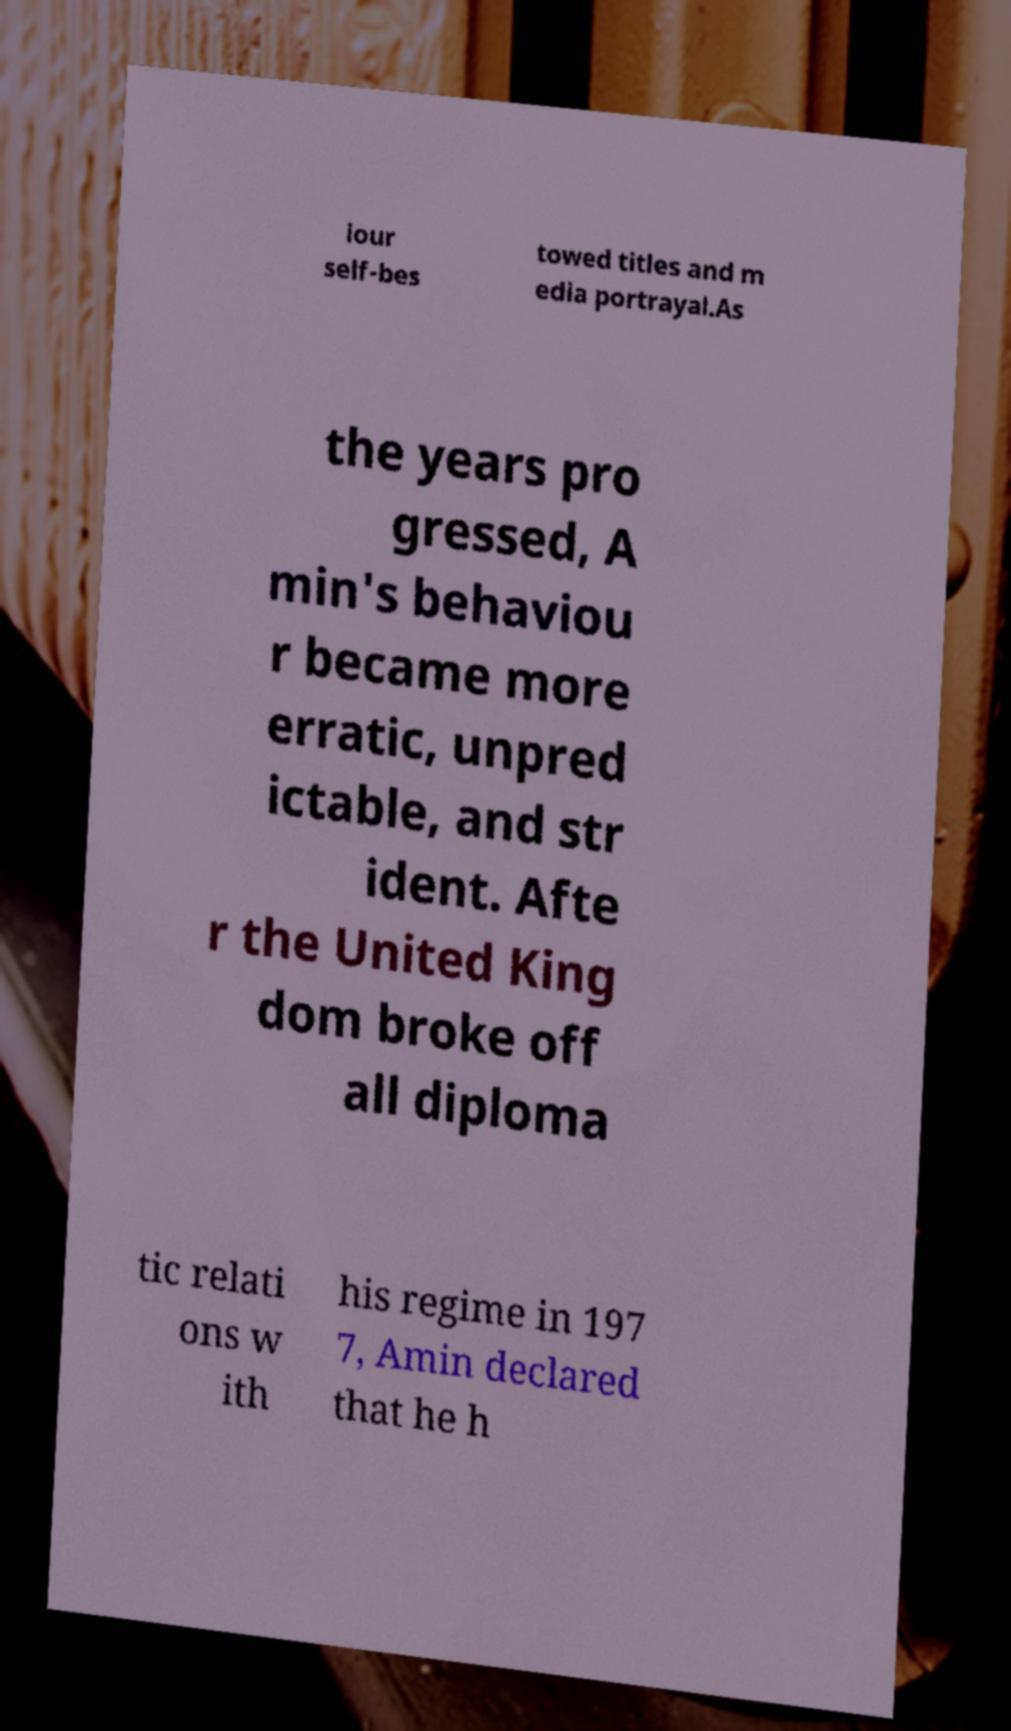Please read and relay the text visible in this image. What does it say? iour self-bes towed titles and m edia portrayal.As the years pro gressed, A min's behaviou r became more erratic, unpred ictable, and str ident. Afte r the United King dom broke off all diploma tic relati ons w ith his regime in 197 7, Amin declared that he h 